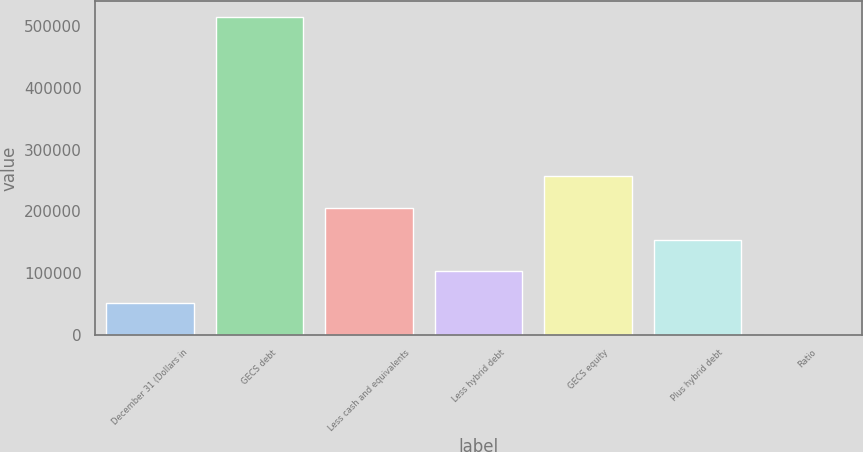Convert chart to OTSL. <chart><loc_0><loc_0><loc_500><loc_500><bar_chart><fcel>December 31 (Dollars in<fcel>GECS debt<fcel>Less cash and equivalents<fcel>Less hybrid debt<fcel>GECS equity<fcel>Plus hybrid debt<fcel>Ratio<nl><fcel>51449.9<fcel>514430<fcel>205777<fcel>102892<fcel>257219<fcel>154334<fcel>7.69<nl></chart> 